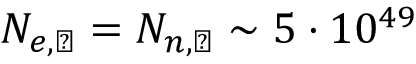Convert formula to latex. <formula><loc_0><loc_0><loc_500><loc_500>N _ { e , \left m o o n } = N _ { n , \left m o o n } \sim 5 \cdot 1 0 ^ { 4 9 }</formula> 